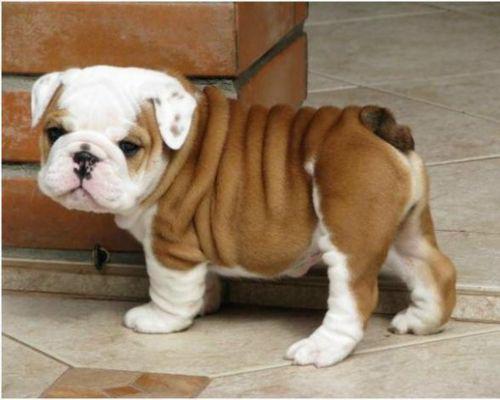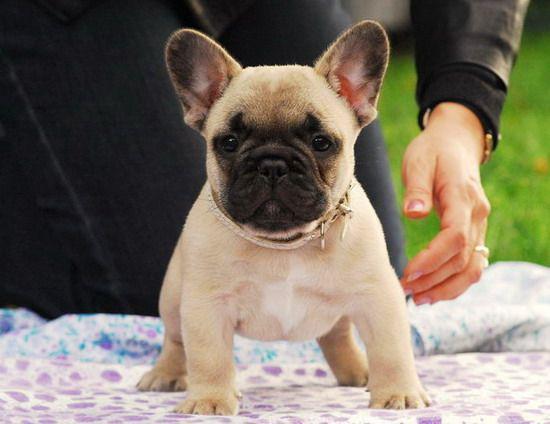The first image is the image on the left, the second image is the image on the right. Analyze the images presented: Is the assertion "Each image shows one dog standing on all fours, and one image shows a dog standing with its body in profile." valid? Answer yes or no. Yes. The first image is the image on the left, the second image is the image on the right. Assess this claim about the two images: "One dog is wearing something around his neck.". Correct or not? Answer yes or no. Yes. 